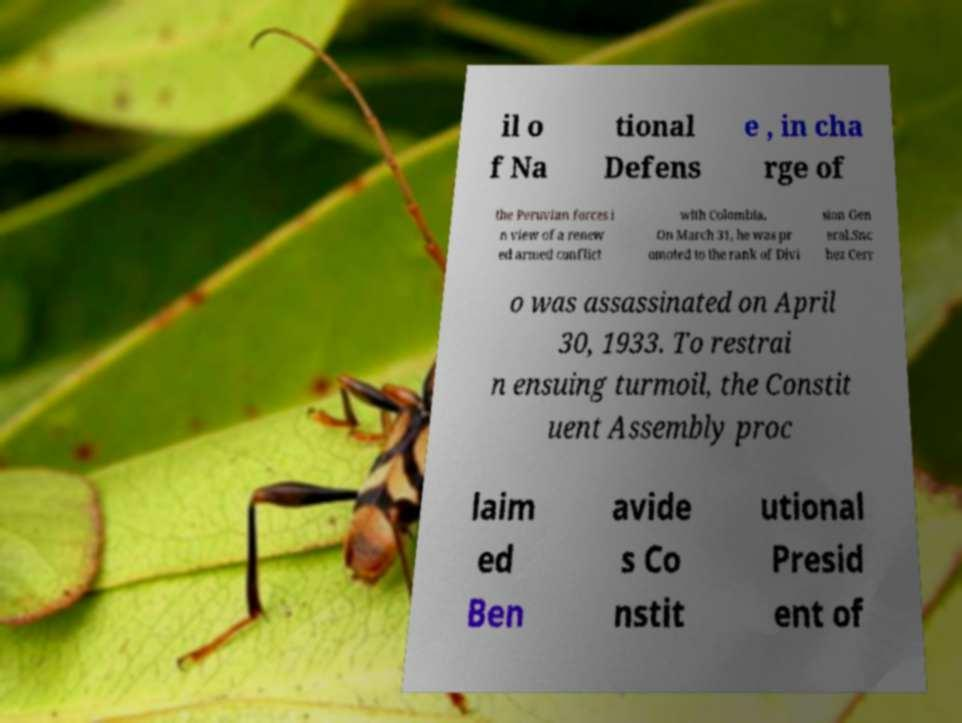Please read and relay the text visible in this image. What does it say? il o f Na tional Defens e , in cha rge of the Peruvian forces i n view of a renew ed armed conflict with Colombia. On March 31, he was pr omoted to the rank of Divi sion Gen eral.Snc hez Cerr o was assassinated on April 30, 1933. To restrai n ensuing turmoil, the Constit uent Assembly proc laim ed Ben avide s Co nstit utional Presid ent of 